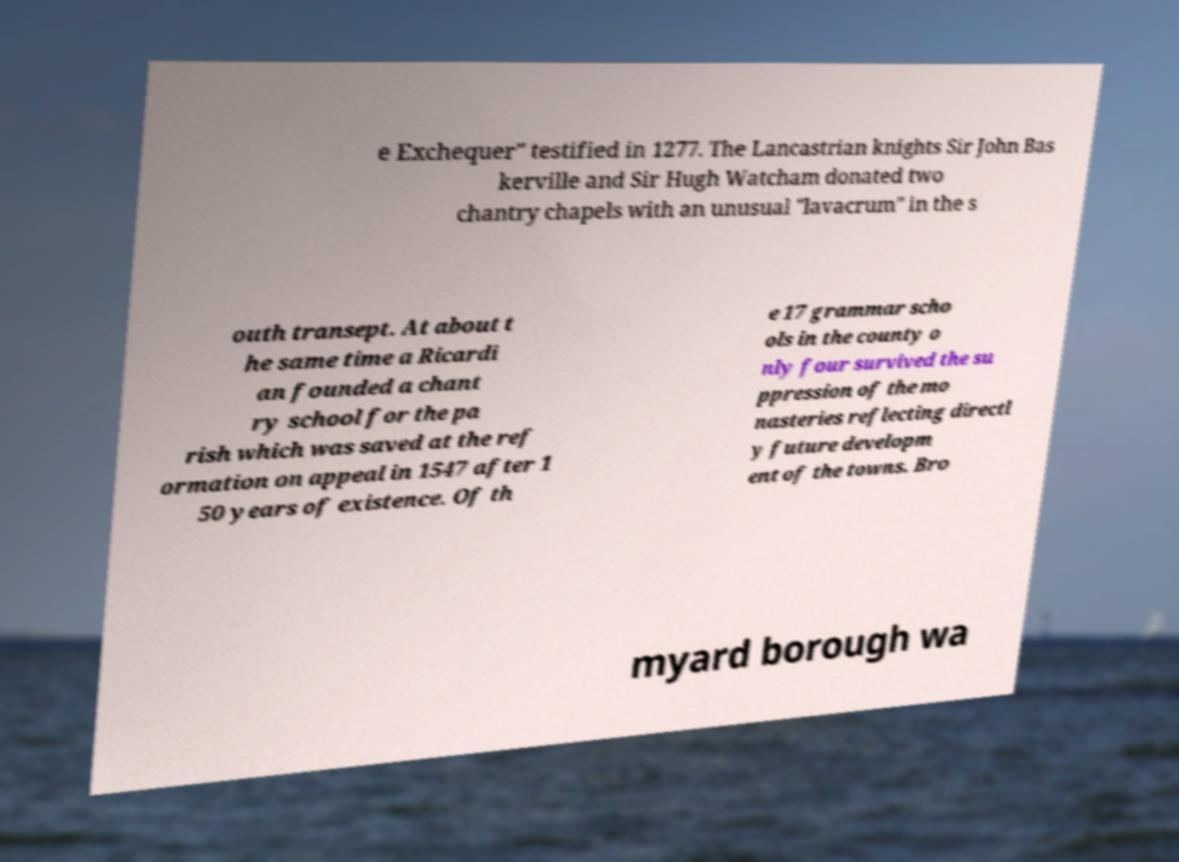I need the written content from this picture converted into text. Can you do that? e Exchequer" testified in 1277. The Lancastrian knights Sir John Bas kerville and Sir Hugh Watcham donated two chantry chapels with an unusual "lavacrum" in the s outh transept. At about t he same time a Ricardi an founded a chant ry school for the pa rish which was saved at the ref ormation on appeal in 1547 after 1 50 years of existence. Of th e 17 grammar scho ols in the county o nly four survived the su ppression of the mo nasteries reflecting directl y future developm ent of the towns. Bro myard borough wa 